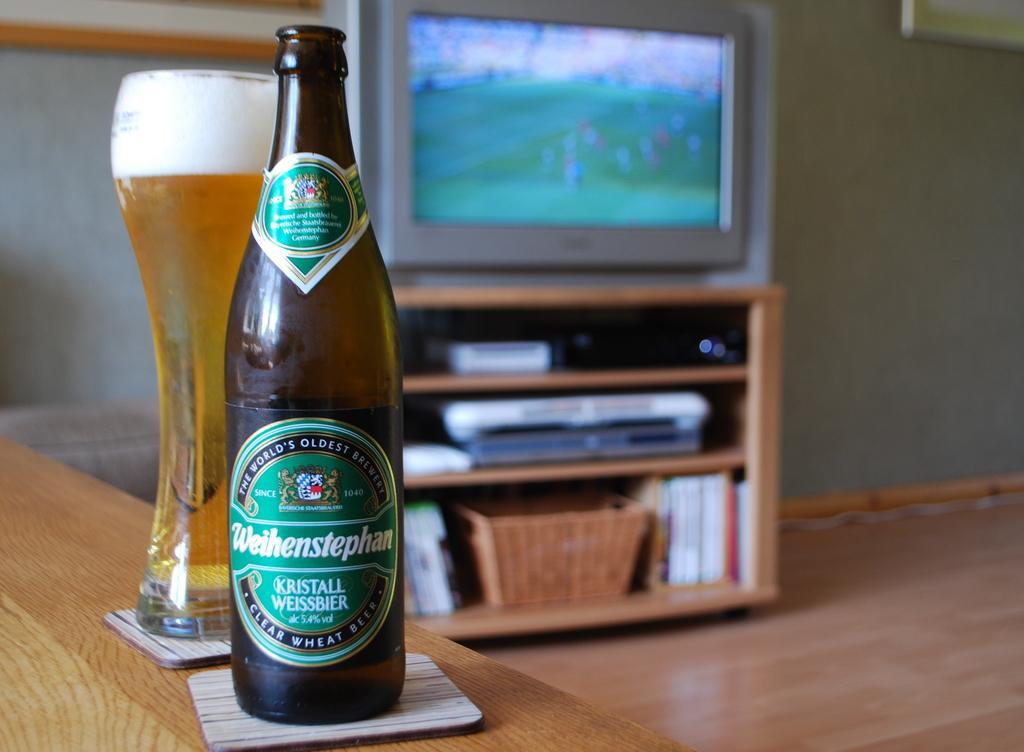<image>
Relay a brief, clear account of the picture shown. A beer bottle that says Weihenstephan is next to a full glass. 